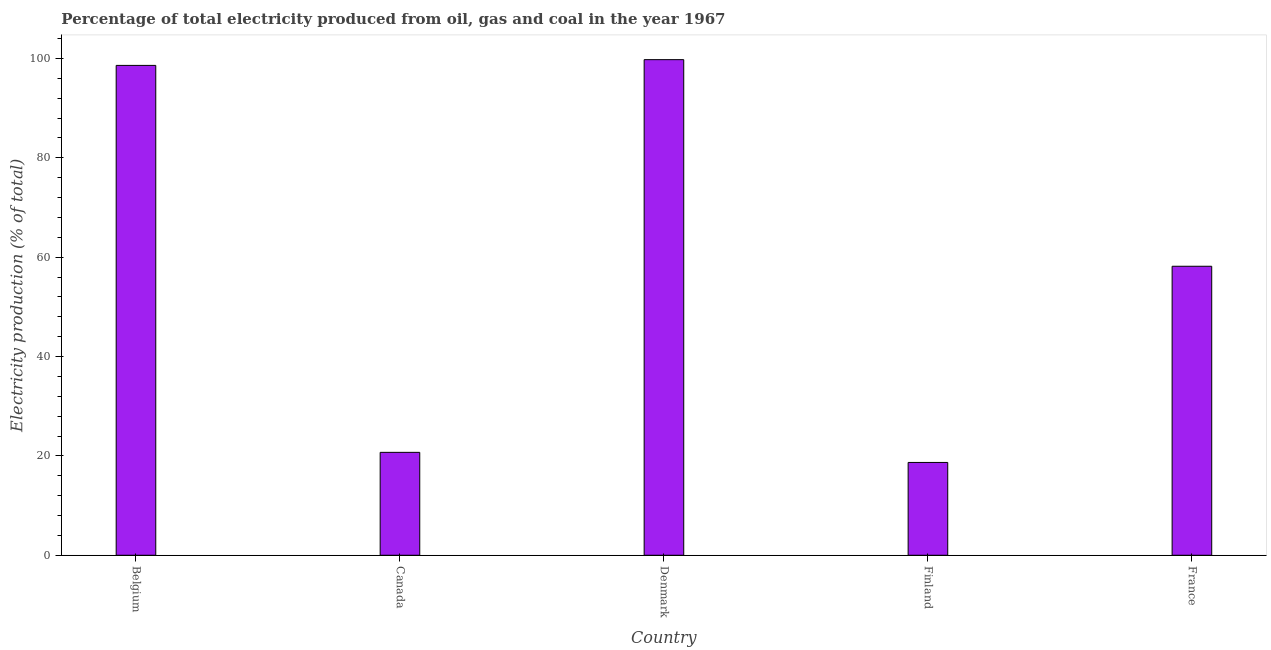Does the graph contain any zero values?
Ensure brevity in your answer.  No. What is the title of the graph?
Give a very brief answer. Percentage of total electricity produced from oil, gas and coal in the year 1967. What is the label or title of the X-axis?
Keep it short and to the point. Country. What is the label or title of the Y-axis?
Keep it short and to the point. Electricity production (% of total). What is the electricity production in France?
Your response must be concise. 58.17. Across all countries, what is the maximum electricity production?
Keep it short and to the point. 99.75. Across all countries, what is the minimum electricity production?
Your answer should be very brief. 18.68. In which country was the electricity production maximum?
Keep it short and to the point. Denmark. What is the sum of the electricity production?
Offer a very short reply. 295.91. What is the difference between the electricity production in Canada and Finland?
Provide a short and direct response. 2.03. What is the average electricity production per country?
Give a very brief answer. 59.18. What is the median electricity production?
Offer a very short reply. 58.17. In how many countries, is the electricity production greater than 20 %?
Give a very brief answer. 4. What is the ratio of the electricity production in Belgium to that in France?
Offer a terse response. 1.7. Is the electricity production in Denmark less than that in France?
Offer a terse response. No. Is the difference between the electricity production in Denmark and Finland greater than the difference between any two countries?
Your answer should be very brief. Yes. What is the difference between the highest and the second highest electricity production?
Give a very brief answer. 1.16. Is the sum of the electricity production in Belgium and France greater than the maximum electricity production across all countries?
Keep it short and to the point. Yes. What is the difference between the highest and the lowest electricity production?
Provide a succinct answer. 81.07. In how many countries, is the electricity production greater than the average electricity production taken over all countries?
Offer a terse response. 2. How many countries are there in the graph?
Give a very brief answer. 5. What is the Electricity production (% of total) of Belgium?
Your response must be concise. 98.6. What is the Electricity production (% of total) of Canada?
Your answer should be very brief. 20.71. What is the Electricity production (% of total) in Denmark?
Your answer should be very brief. 99.75. What is the Electricity production (% of total) of Finland?
Offer a very short reply. 18.68. What is the Electricity production (% of total) in France?
Make the answer very short. 58.17. What is the difference between the Electricity production (% of total) in Belgium and Canada?
Your response must be concise. 77.89. What is the difference between the Electricity production (% of total) in Belgium and Denmark?
Keep it short and to the point. -1.15. What is the difference between the Electricity production (% of total) in Belgium and Finland?
Keep it short and to the point. 79.92. What is the difference between the Electricity production (% of total) in Belgium and France?
Provide a short and direct response. 40.43. What is the difference between the Electricity production (% of total) in Canada and Denmark?
Ensure brevity in your answer.  -79.04. What is the difference between the Electricity production (% of total) in Canada and Finland?
Provide a succinct answer. 2.03. What is the difference between the Electricity production (% of total) in Canada and France?
Offer a terse response. -37.46. What is the difference between the Electricity production (% of total) in Denmark and Finland?
Your answer should be compact. 81.07. What is the difference between the Electricity production (% of total) in Denmark and France?
Provide a succinct answer. 41.58. What is the difference between the Electricity production (% of total) in Finland and France?
Your answer should be very brief. -39.49. What is the ratio of the Electricity production (% of total) in Belgium to that in Canada?
Offer a very short reply. 4.76. What is the ratio of the Electricity production (% of total) in Belgium to that in Finland?
Your answer should be compact. 5.28. What is the ratio of the Electricity production (% of total) in Belgium to that in France?
Offer a very short reply. 1.7. What is the ratio of the Electricity production (% of total) in Canada to that in Denmark?
Make the answer very short. 0.21. What is the ratio of the Electricity production (% of total) in Canada to that in Finland?
Your answer should be compact. 1.11. What is the ratio of the Electricity production (% of total) in Canada to that in France?
Offer a terse response. 0.36. What is the ratio of the Electricity production (% of total) in Denmark to that in Finland?
Ensure brevity in your answer.  5.34. What is the ratio of the Electricity production (% of total) in Denmark to that in France?
Your answer should be very brief. 1.72. What is the ratio of the Electricity production (% of total) in Finland to that in France?
Your answer should be very brief. 0.32. 